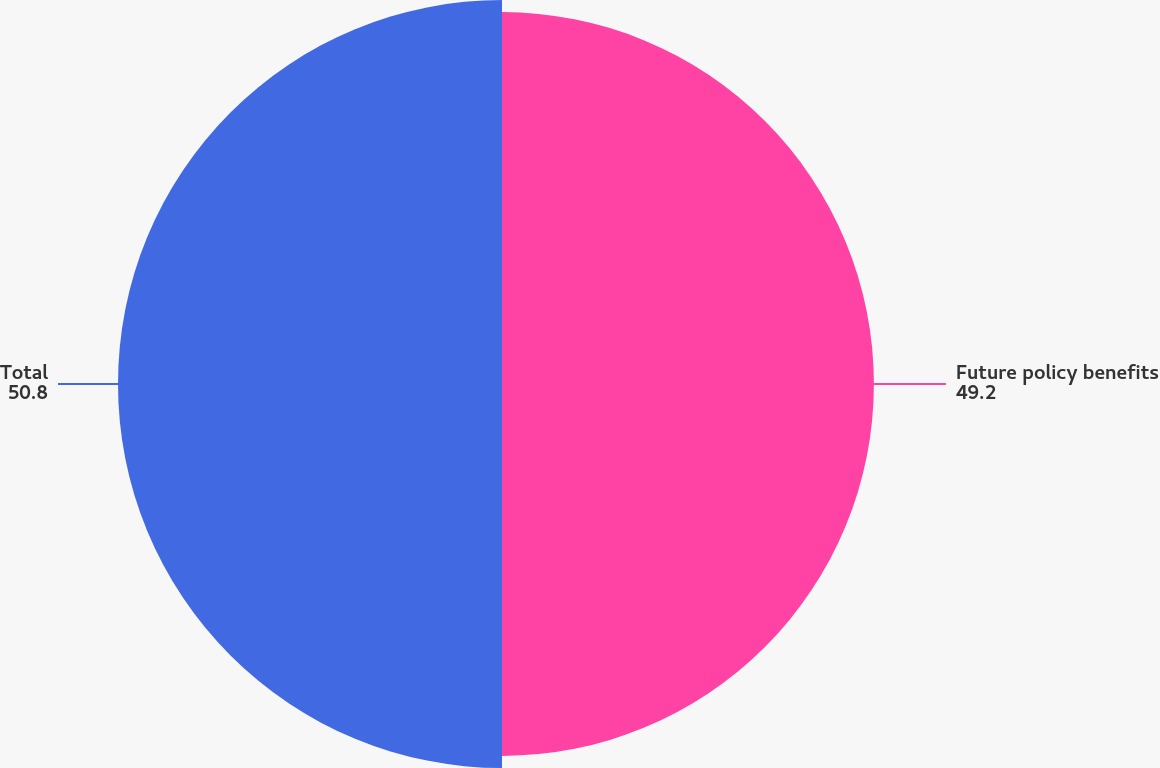<chart> <loc_0><loc_0><loc_500><loc_500><pie_chart><fcel>Future policy benefits<fcel>Total<nl><fcel>49.2%<fcel>50.8%<nl></chart> 